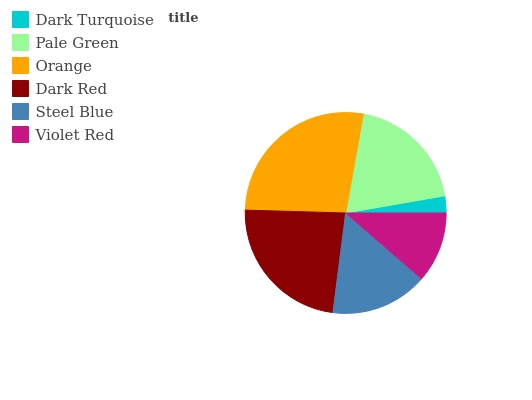Is Dark Turquoise the minimum?
Answer yes or no. Yes. Is Orange the maximum?
Answer yes or no. Yes. Is Pale Green the minimum?
Answer yes or no. No. Is Pale Green the maximum?
Answer yes or no. No. Is Pale Green greater than Dark Turquoise?
Answer yes or no. Yes. Is Dark Turquoise less than Pale Green?
Answer yes or no. Yes. Is Dark Turquoise greater than Pale Green?
Answer yes or no. No. Is Pale Green less than Dark Turquoise?
Answer yes or no. No. Is Pale Green the high median?
Answer yes or no. Yes. Is Steel Blue the low median?
Answer yes or no. Yes. Is Orange the high median?
Answer yes or no. No. Is Dark Red the low median?
Answer yes or no. No. 